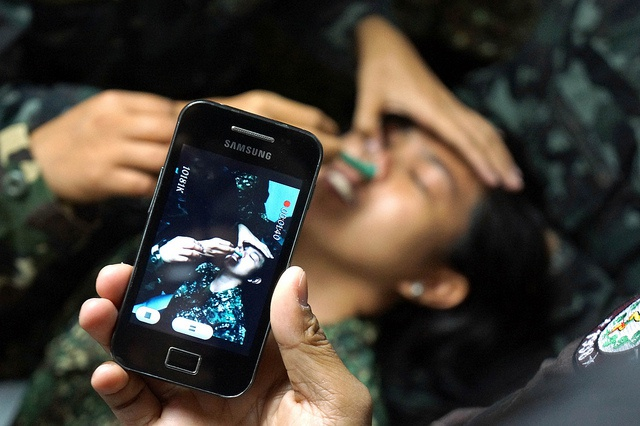Describe the objects in this image and their specific colors. I can see people in black, gray, and maroon tones, cell phone in black, white, navy, and gray tones, people in black and tan tones, people in black and tan tones, and people in black, maroon, and tan tones in this image. 